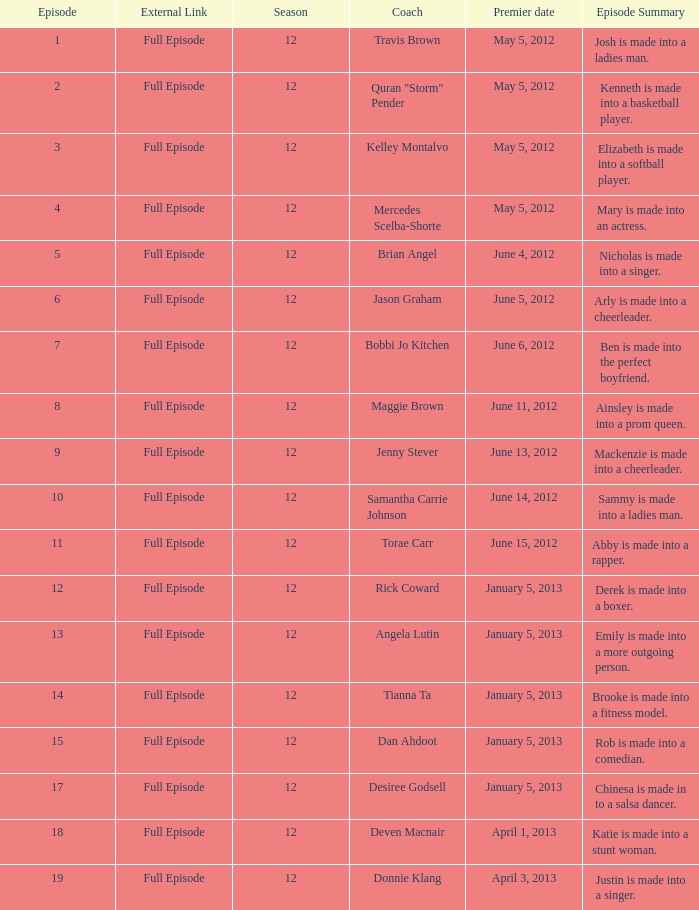Name the episode summary for travis brown Josh is made into a ladies man. 